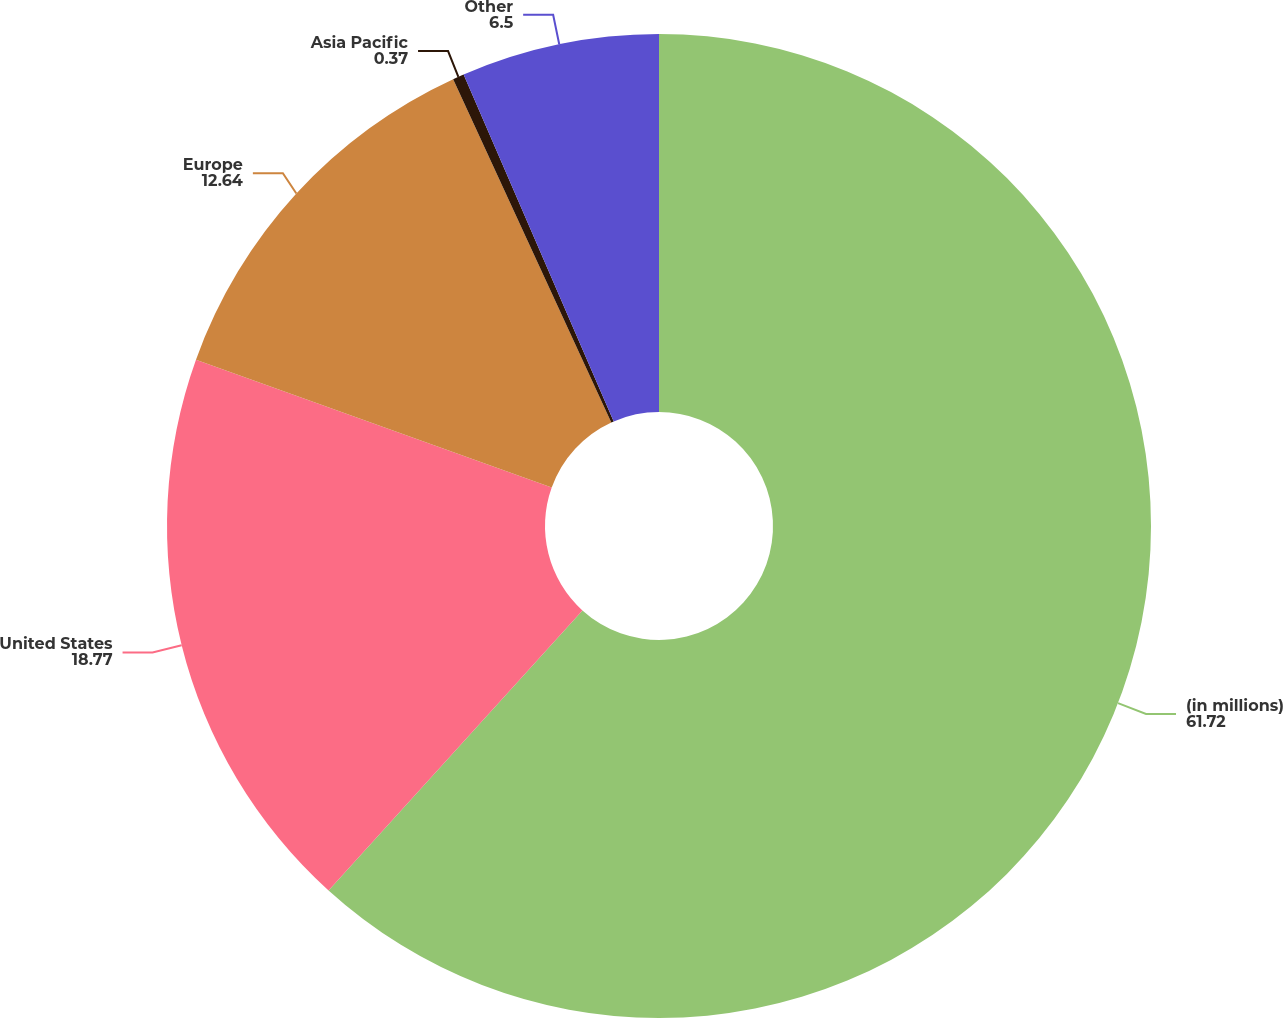Convert chart. <chart><loc_0><loc_0><loc_500><loc_500><pie_chart><fcel>(in millions)<fcel>United States<fcel>Europe<fcel>Asia Pacific<fcel>Other<nl><fcel>61.72%<fcel>18.77%<fcel>12.64%<fcel>0.37%<fcel>6.5%<nl></chart> 